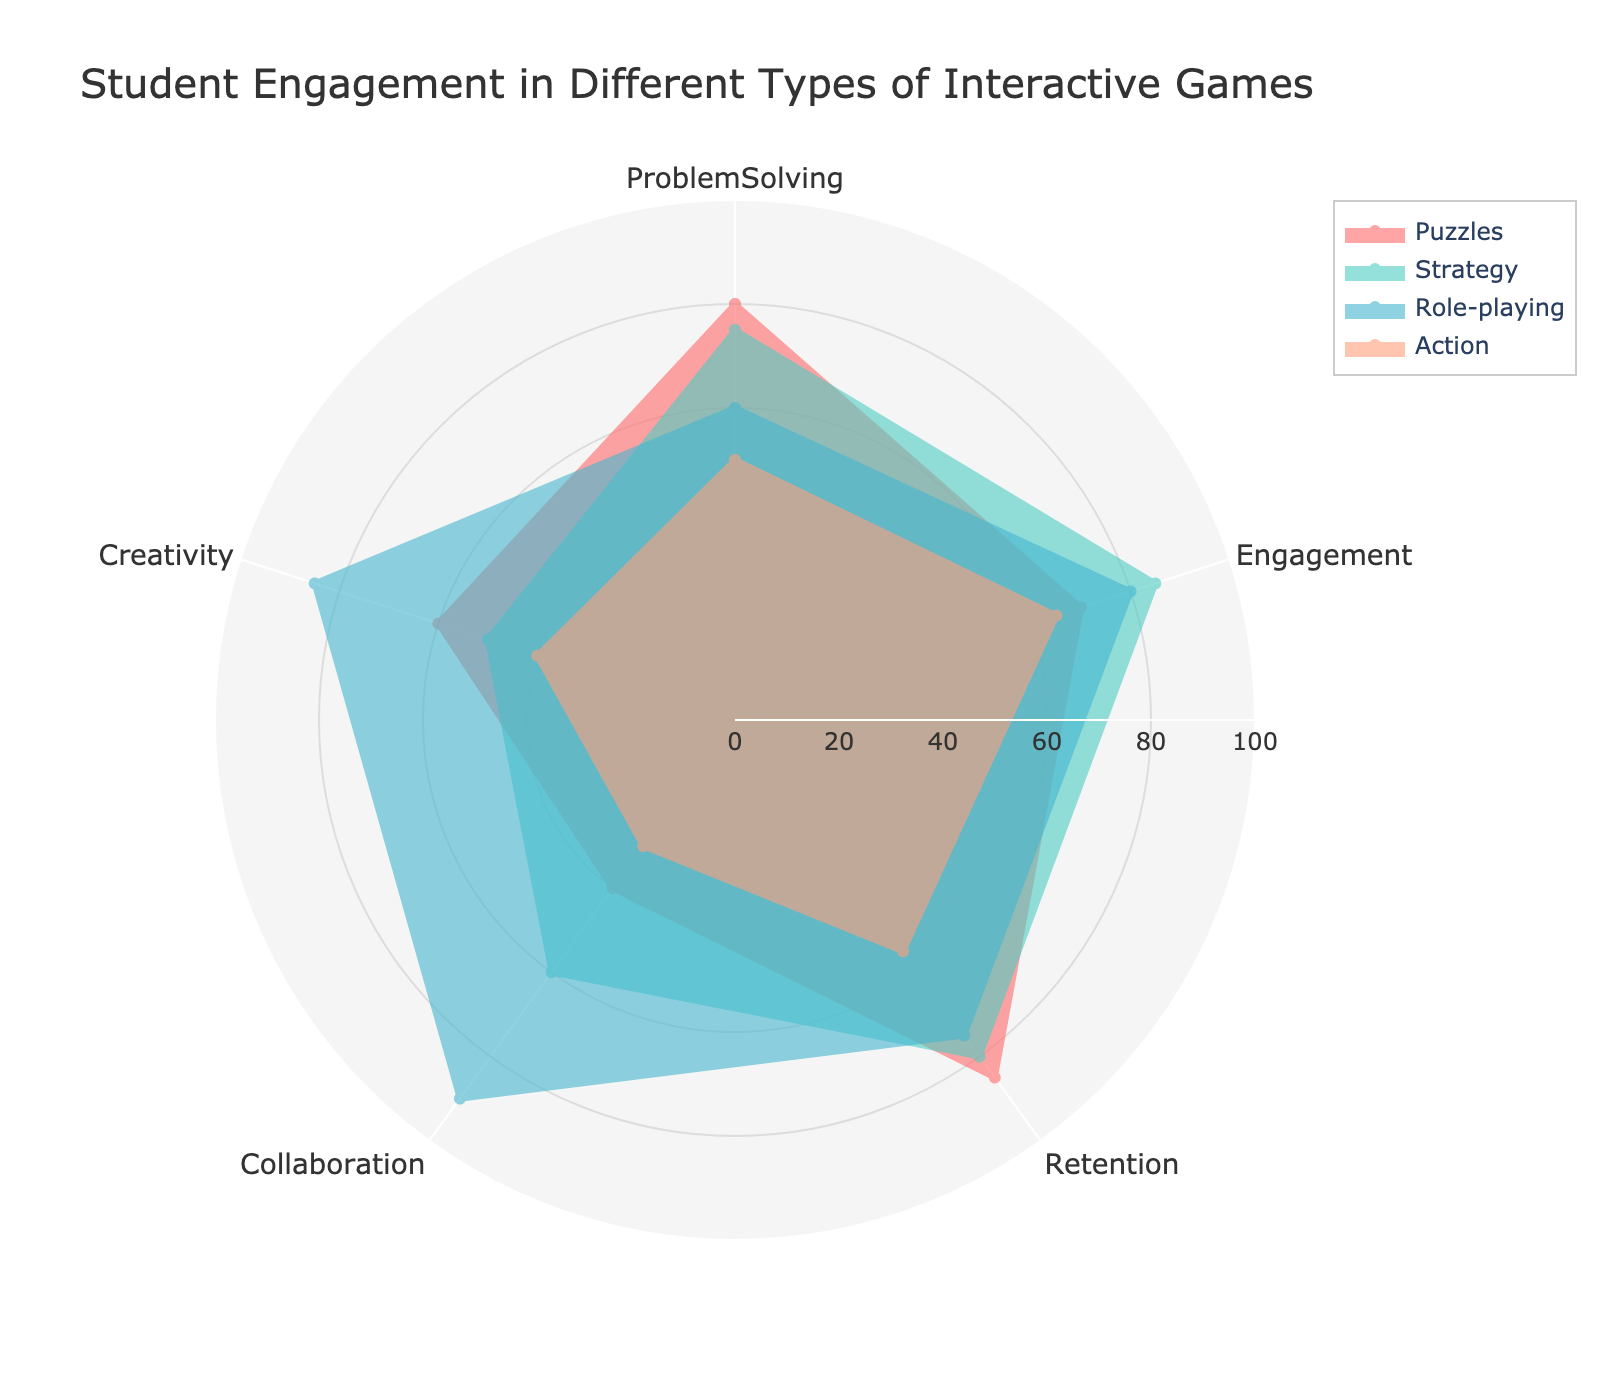What is the title of the polar chart? The title of the chart is located near the top and indicates what the chart represents.
Answer: Student Engagement in Different Types of Interactive Games Which game type has the highest engagement value? Examine the 'Engagement' axis and compare the values for all game types. Role-playing has the highest engagement value, shown by the darkest color segment on its respective plot.
Answer: Role-playing Which game type scored the lowest in creativity? Look at the 'Creativity' axis and find the smallest value. Action scored the lowest in creativity with a lighter segment on its plot.
Answer: Action What is the average retention score of all game types? Sum the retention scores for each game type and divide by the number of game types: (85 + 80 + 75 + 55) / 4.
Answer: 73.75 Which game type shows the greatest variability across all metrics? Compare the range of values for each game type. Role-playing shows the broadest range from 30 (lowest) to 90 (highest), indicating the greatest variability.
Answer: Role-playing On which attribute do puzzles and strategy games have the closest values? Check each attribute and find the smallest difference between the scores of puzzles and strategy games. The closest values are in the 'ProblemSolving' attribute (80 for Puzzles and 75 for Strategy, a difference of 5).
Answer: ProblemSolving Which game type excels the most in collaboration? Look at the ‘Collaboration’ axis and identify the game type with the highest value. Role-playing games excel most in collaboration with a value of 90.
Answer: Role-playing What is the combined engagement score for puzzles and action games? Add the engagement scores for puzzles and action games (70 + 65).
Answer: 135 How much higher is the problem-solving score for puzzles than for role-playing games? Subtract the problem-solving score of role-playing games from that of puzzles (80 - 60).
Answer: 20 What is the second-highest score in creativity among the game types? Compare the creativity scores and find the second highest. The highest is Role-playing with 85; the second-highest is Puzzles with 60.
Answer: Puzzles 